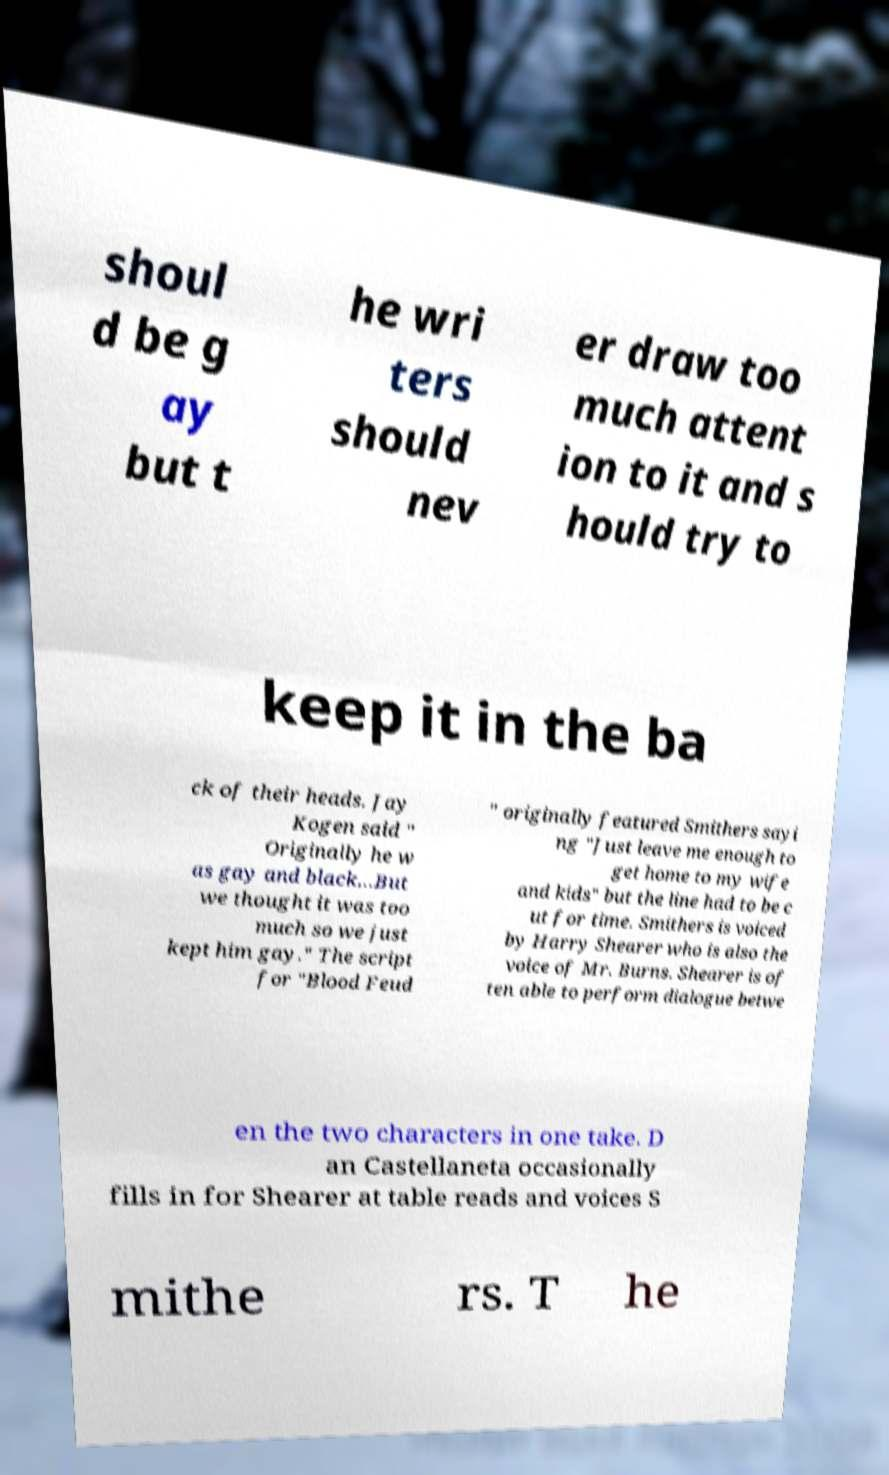I need the written content from this picture converted into text. Can you do that? shoul d be g ay but t he wri ters should nev er draw too much attent ion to it and s hould try to keep it in the ba ck of their heads. Jay Kogen said " Originally he w as gay and black...But we thought it was too much so we just kept him gay." The script for "Blood Feud " originally featured Smithers sayi ng "Just leave me enough to get home to my wife and kids" but the line had to be c ut for time. Smithers is voiced by Harry Shearer who is also the voice of Mr. Burns. Shearer is of ten able to perform dialogue betwe en the two characters in one take. D an Castellaneta occasionally fills in for Shearer at table reads and voices S mithe rs. T he 